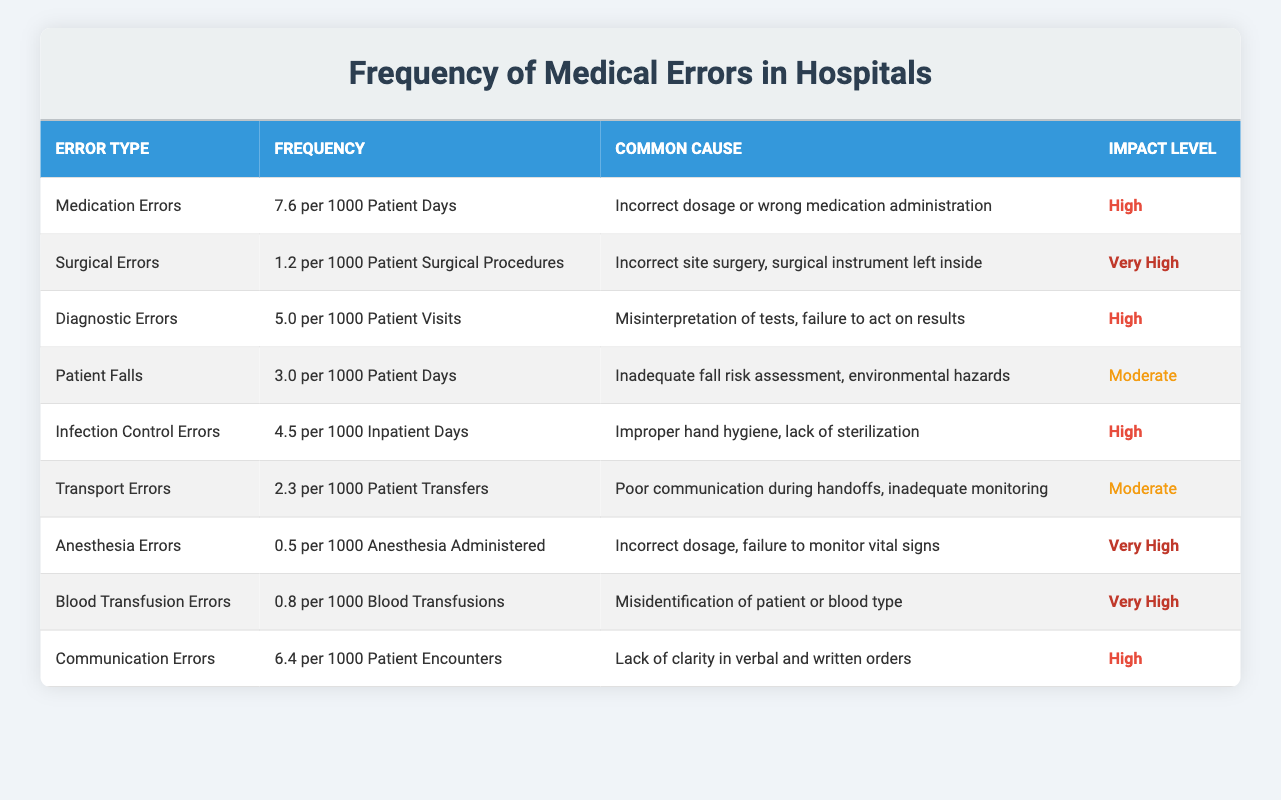What is the frequency of Medication Errors? The table lists that Medication Errors occur at a frequency of 7.6 per 1000 Patient Days.
Answer: 7.6 per 1000 Patient Days What is the common cause of Surgical Errors? According to the table, the common cause of Surgical Errors is "Incorrect site surgery, surgical instrument left inside."
Answer: Incorrect site surgery, surgical instrument left inside How many types of medical errors have a 'High' Impact Level? By reviewing the table, the types of medical errors with a 'High' Impact Level are Medication Errors, Diagnostic Errors, Infection Control Errors, and Communication Errors—totaling four types.
Answer: 4 What is the frequency difference between Patient Falls and Transport Errors? Patient Falls occur at a frequency of 3.0 per 1000 Patient Days, while Transport Errors occur at 2.3 per 1000 Patient Transfers. The difference is calculated as 3.0 - 2.3 = 0.7.
Answer: 0.7 Do Anesthesia Errors have a higher frequency than Blood Transfusion Errors? Anesthesia Errors have a frequency of 0.5 per 1000 Anesthesia Administered, while Blood Transfusion Errors have a frequency of 0.8 per 1000 Blood Transfusions. Since 0.5 is less than 0.8, the statement is false.
Answer: No What is the average frequency of errors categorized as 'Very High'? From the table, there are three types of errors categorized as 'Very High': Surgical Errors (1.2), Anesthesia Errors (0.5), and Blood Transfusion Errors (0.8). The average is calculated as (1.2 + 0.5 + 0.8) / 3 = 2.5 / 3 = approximately 0.83.
Answer: 0.83 Which type of medical error has the lowest frequency? Reviewing the table, Anesthesia Errors have the lowest frequency at 0.5 per 1000 Anesthesia Administered.
Answer: Anesthesia Errors Are more medical errors related to communication issues or surgical procedures? Communication Errors have a frequency of 6.4 per 1000 Patient Encounters, while Surgical Errors have a frequency of 1.2 per 1000 Patient Surgical Procedures. Since 6.4 is greater than 1.2, more errors are related to communication issues.
Answer: Yes 